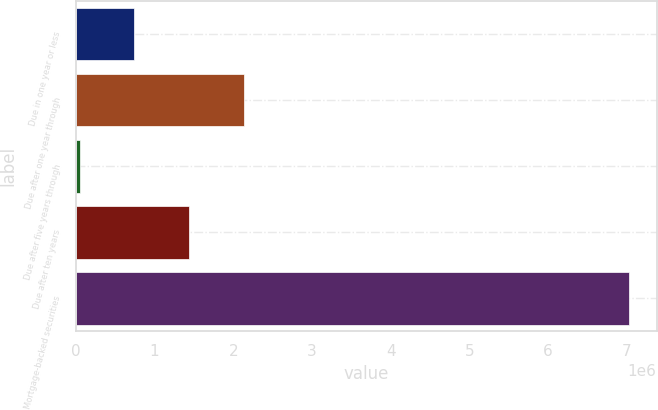Convert chart. <chart><loc_0><loc_0><loc_500><loc_500><bar_chart><fcel>Due in one year or less<fcel>Due after one year through<fcel>Due after five years through<fcel>Due after ten years<fcel>Mortgage-backed securities<nl><fcel>744514<fcel>2.14054e+06<fcel>46499<fcel>1.44253e+06<fcel>7.02665e+06<nl></chart> 